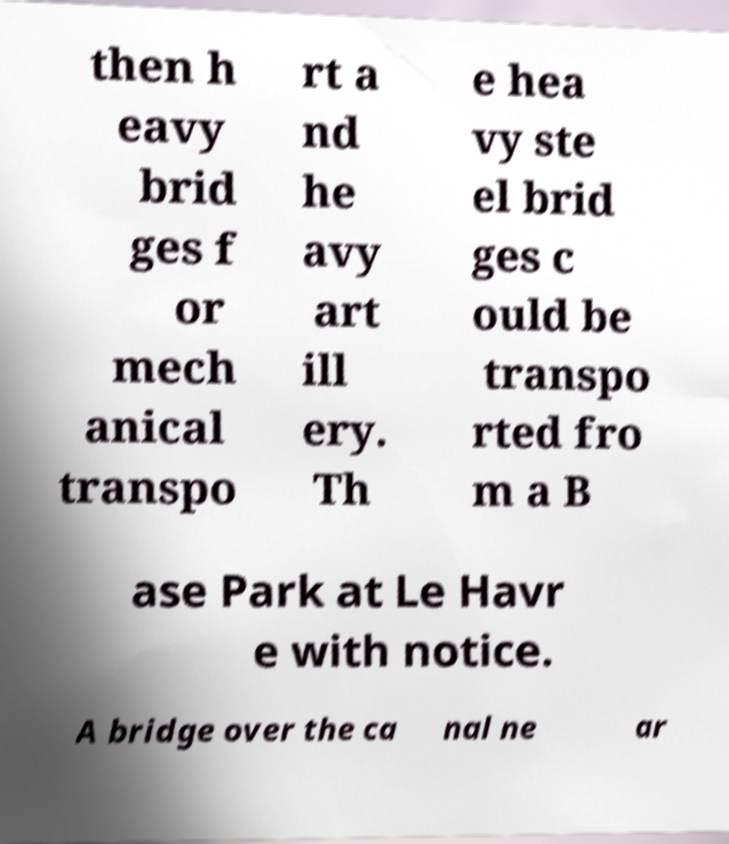For documentation purposes, I need the text within this image transcribed. Could you provide that? then h eavy brid ges f or mech anical transpo rt a nd he avy art ill ery. Th e hea vy ste el brid ges c ould be transpo rted fro m a B ase Park at Le Havr e with notice. A bridge over the ca nal ne ar 